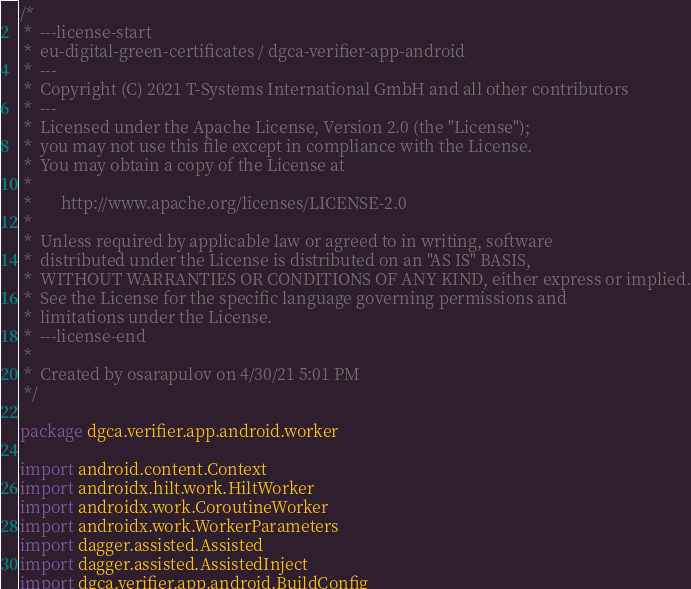<code> <loc_0><loc_0><loc_500><loc_500><_Kotlin_>/*
 *  ---license-start
 *  eu-digital-green-certificates / dgca-verifier-app-android
 *  ---
 *  Copyright (C) 2021 T-Systems International GmbH and all other contributors
 *  ---
 *  Licensed under the Apache License, Version 2.0 (the "License");
 *  you may not use this file except in compliance with the License.
 *  You may obtain a copy of the License at
 *
 *       http://www.apache.org/licenses/LICENSE-2.0
 *
 *  Unless required by applicable law or agreed to in writing, software
 *  distributed under the License is distributed on an "AS IS" BASIS,
 *  WITHOUT WARRANTIES OR CONDITIONS OF ANY KIND, either express or implied.
 *  See the License for the specific language governing permissions and
 *  limitations under the License.
 *  ---license-end
 *
 *  Created by osarapulov on 4/30/21 5:01 PM
 */

package dgca.verifier.app.android.worker

import android.content.Context
import androidx.hilt.work.HiltWorker
import androidx.work.CoroutineWorker
import androidx.work.WorkerParameters
import dagger.assisted.Assisted
import dagger.assisted.AssistedInject
import dgca.verifier.app.android.BuildConfig</code> 